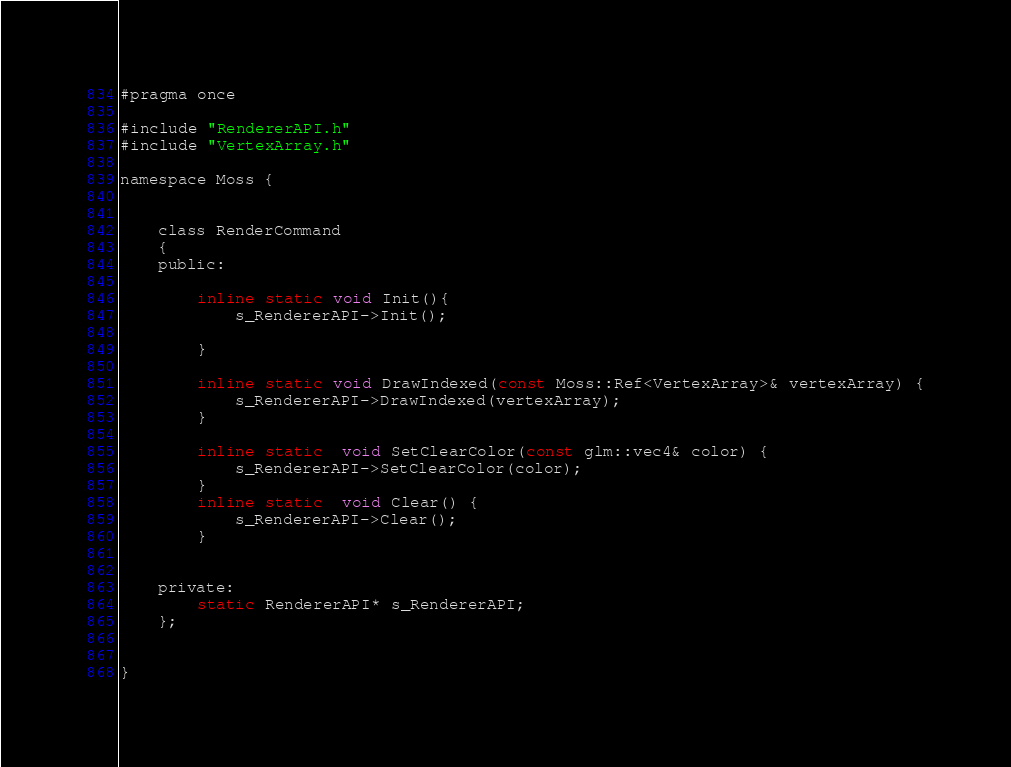<code> <loc_0><loc_0><loc_500><loc_500><_C_>#pragma once

#include "RendererAPI.h"
#include "VertexArray.h"

namespace Moss {


	class RenderCommand
	{
	public:

		inline static void Init(){
			s_RendererAPI->Init();

		}

		inline static void DrawIndexed(const Moss::Ref<VertexArray>& vertexArray) {
			s_RendererAPI->DrawIndexed(vertexArray);
		}

		inline static  void SetClearColor(const glm::vec4& color) {
			s_RendererAPI->SetClearColor(color);
		}
		inline static  void Clear() {
			s_RendererAPI->Clear();
		}


	private:
		static RendererAPI* s_RendererAPI;
	};


}
</code> 